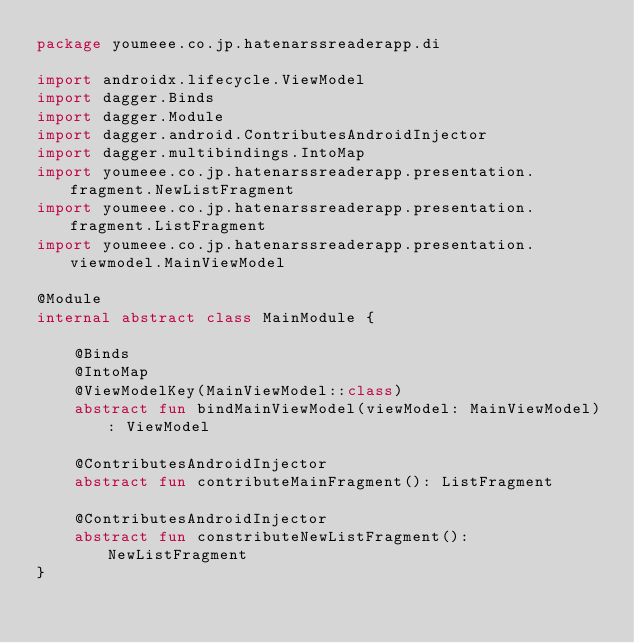Convert code to text. <code><loc_0><loc_0><loc_500><loc_500><_Kotlin_>package youmeee.co.jp.hatenarssreaderapp.di

import androidx.lifecycle.ViewModel
import dagger.Binds
import dagger.Module
import dagger.android.ContributesAndroidInjector
import dagger.multibindings.IntoMap
import youmeee.co.jp.hatenarssreaderapp.presentation.fragment.NewListFragment
import youmeee.co.jp.hatenarssreaderapp.presentation.fragment.ListFragment
import youmeee.co.jp.hatenarssreaderapp.presentation.viewmodel.MainViewModel

@Module
internal abstract class MainModule {

    @Binds
    @IntoMap
    @ViewModelKey(MainViewModel::class)
    abstract fun bindMainViewModel(viewModel: MainViewModel): ViewModel

    @ContributesAndroidInjector
    abstract fun contributeMainFragment(): ListFragment

    @ContributesAndroidInjector
    abstract fun constributeNewListFragment(): NewListFragment
}</code> 